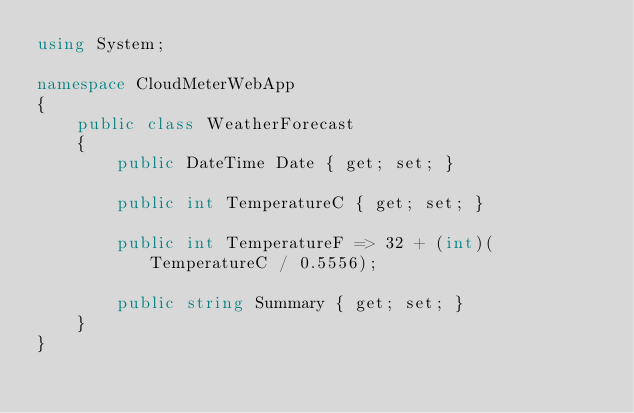<code> <loc_0><loc_0><loc_500><loc_500><_C#_>using System;

namespace CloudMeterWebApp
{
    public class WeatherForecast
    {
        public DateTime Date { get; set; }

        public int TemperatureC { get; set; }

        public int TemperatureF => 32 + (int)(TemperatureC / 0.5556);

        public string Summary { get; set; }
    }
}
</code> 